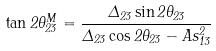<formula> <loc_0><loc_0><loc_500><loc_500>\tan 2 \theta _ { 2 3 } ^ { M } = \frac { \Delta _ { 2 3 } \sin 2 \theta _ { 2 3 } } { \Delta _ { 2 3 } \cos 2 \theta _ { 2 3 } - A s _ { 1 3 } ^ { 2 } }</formula> 